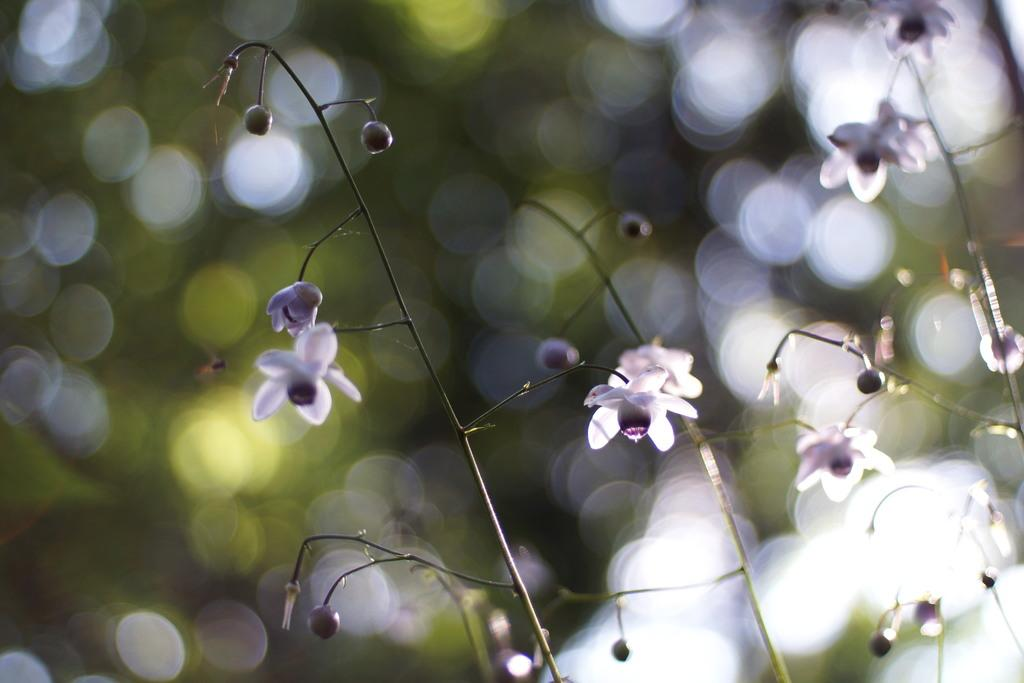What type of plants are visible in the image? There are small plants in the image. Where are the small plants located? The small plants are on a plant. How many trucks can be seen driving through the image? There are no trucks present in the image; it features small plants on a plant. 